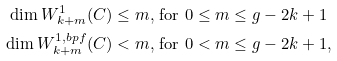<formula> <loc_0><loc_0><loc_500><loc_500>\dim W ^ { 1 } _ { k + m } ( C ) & \leq m , \, \text {for $0 \leq m \leq g-2k+1$} \\ \dim W ^ { 1 , b p f } _ { k + m } ( C ) & < m , \, \text {for $0 < m \leq g-2k+1$} ,</formula> 